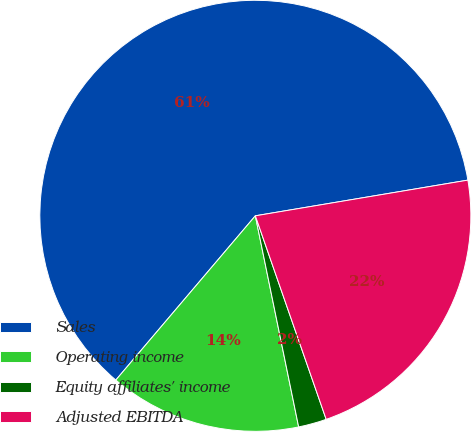Convert chart. <chart><loc_0><loc_0><loc_500><loc_500><pie_chart><fcel>Sales<fcel>Operating income<fcel>Equity affiliates' income<fcel>Adjusted EBITDA<nl><fcel>61.15%<fcel>14.43%<fcel>2.11%<fcel>22.32%<nl></chart> 